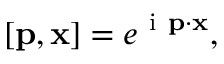Convert formula to latex. <formula><loc_0><loc_0><loc_500><loc_500>{ \Psi } [ { p } , { x } ] = e ^ { i { p } \cdot { x } } ,</formula> 